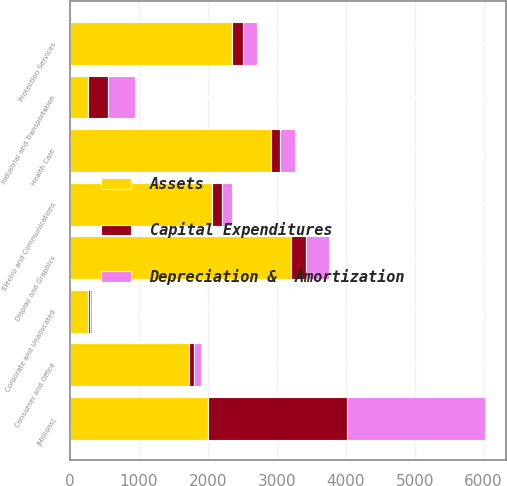Convert chart to OTSL. <chart><loc_0><loc_0><loc_500><loc_500><stacked_bar_chart><ecel><fcel>(Millions)<fcel>Industrial and Transportation<fcel>Health Care<fcel>Display and Graphics<fcel>Consumer and Office<fcel>Protection Services<fcel>Electro and Communications<fcel>Corporate and Unallocated<nl><fcel>Assets<fcel>2007<fcel>258<fcel>2909<fcel>3199<fcel>1720<fcel>2344<fcel>2063<fcel>258<nl><fcel>Capital Expenditures<fcel>2007<fcel>294<fcel>138<fcel>222<fcel>82<fcel>161<fcel>146<fcel>29<nl><fcel>Depreciation &  Amortization<fcel>2007<fcel>396<fcel>213<fcel>341<fcel>101<fcel>205<fcel>136<fcel>30<nl></chart> 